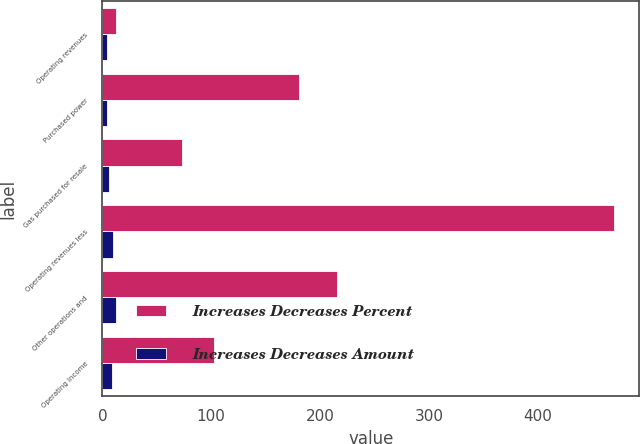<chart> <loc_0><loc_0><loc_500><loc_500><stacked_bar_chart><ecel><fcel>Operating revenues<fcel>Purchased power<fcel>Gas purchased for resale<fcel>Operating revenues less<fcel>Other operations and<fcel>Operating income<nl><fcel>Increases Decreases Percent<fcel>12.8<fcel>181<fcel>73<fcel>470<fcel>216<fcel>103<nl><fcel>Increases Decreases Amount<fcel>4.3<fcel>3.9<fcel>6.3<fcel>9.5<fcel>12.8<fcel>8.9<nl></chart> 